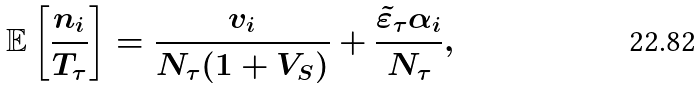Convert formula to latex. <formula><loc_0><loc_0><loc_500><loc_500>\mathbb { E } \left [ \frac { n _ { i } } { T _ { \tau } } \right ] = \frac { v _ { i } } { N _ { \tau } ( 1 + V _ { S } ) } + \frac { \tilde { \varepsilon } _ { \tau } \alpha _ { i } } { N _ { \tau } } ,</formula> 